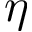<formula> <loc_0><loc_0><loc_500><loc_500>\eta</formula> 